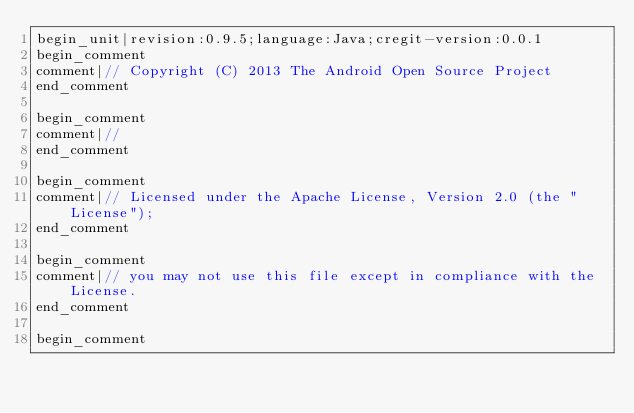<code> <loc_0><loc_0><loc_500><loc_500><_Java_>begin_unit|revision:0.9.5;language:Java;cregit-version:0.0.1
begin_comment
comment|// Copyright (C) 2013 The Android Open Source Project
end_comment

begin_comment
comment|//
end_comment

begin_comment
comment|// Licensed under the Apache License, Version 2.0 (the "License");
end_comment

begin_comment
comment|// you may not use this file except in compliance with the License.
end_comment

begin_comment</code> 